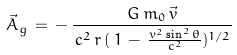Convert formula to latex. <formula><loc_0><loc_0><loc_500><loc_500>\vec { A } _ { g } \, = \, - \, \frac { G \, m _ { 0 } \, \vec { v } } { \, c ^ { 2 } \, r \, ( \, 1 \, - \, \frac { v ^ { 2 } \sin ^ { 2 } \theta } { c ^ { 2 } } ) ^ { 1 / 2 } }</formula> 